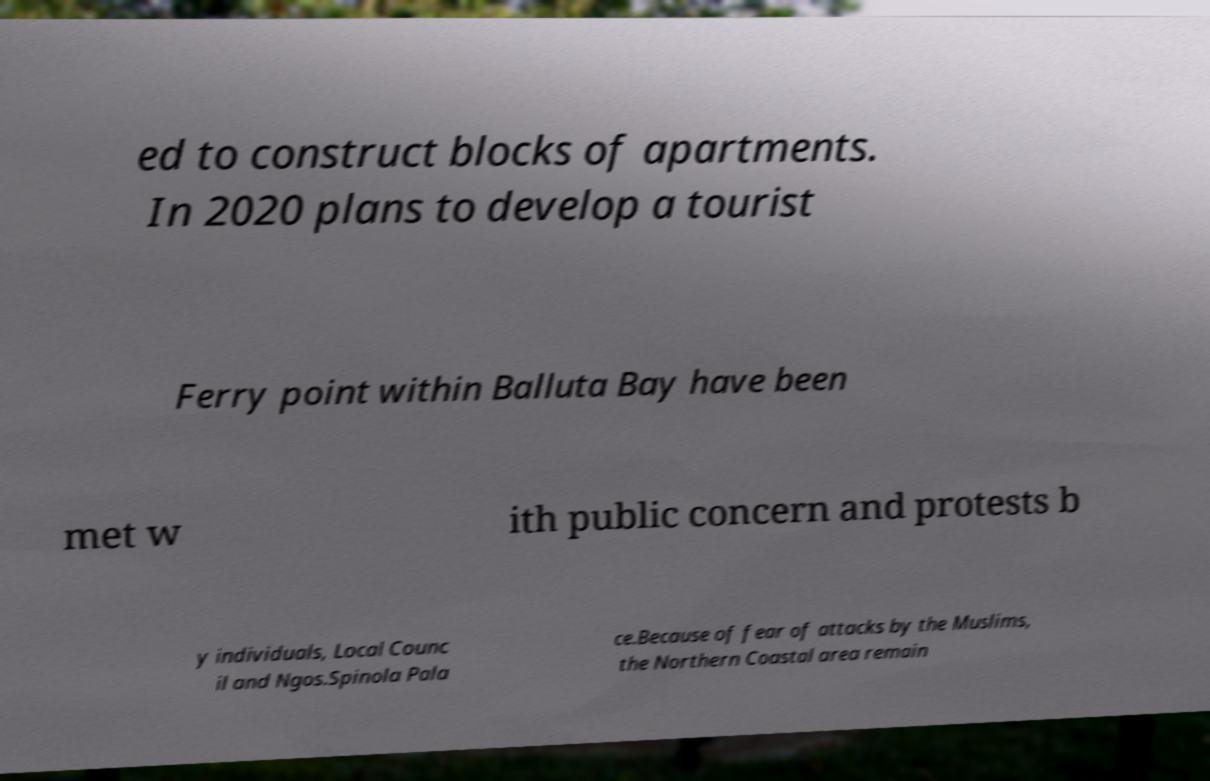Could you extract and type out the text from this image? ed to construct blocks of apartments. In 2020 plans to develop a tourist Ferry point within Balluta Bay have been met w ith public concern and protests b y individuals, Local Counc il and Ngos.Spinola Pala ce.Because of fear of attacks by the Muslims, the Northern Coastal area remain 